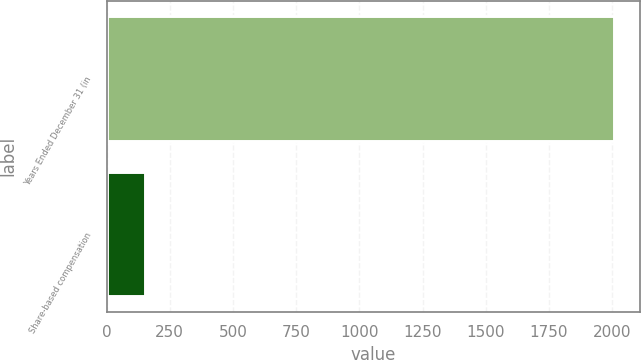Convert chart to OTSL. <chart><loc_0><loc_0><loc_500><loc_500><bar_chart><fcel>Years Ended December 31 (in<fcel>Share-based compensation<nl><fcel>2009<fcel>151<nl></chart> 